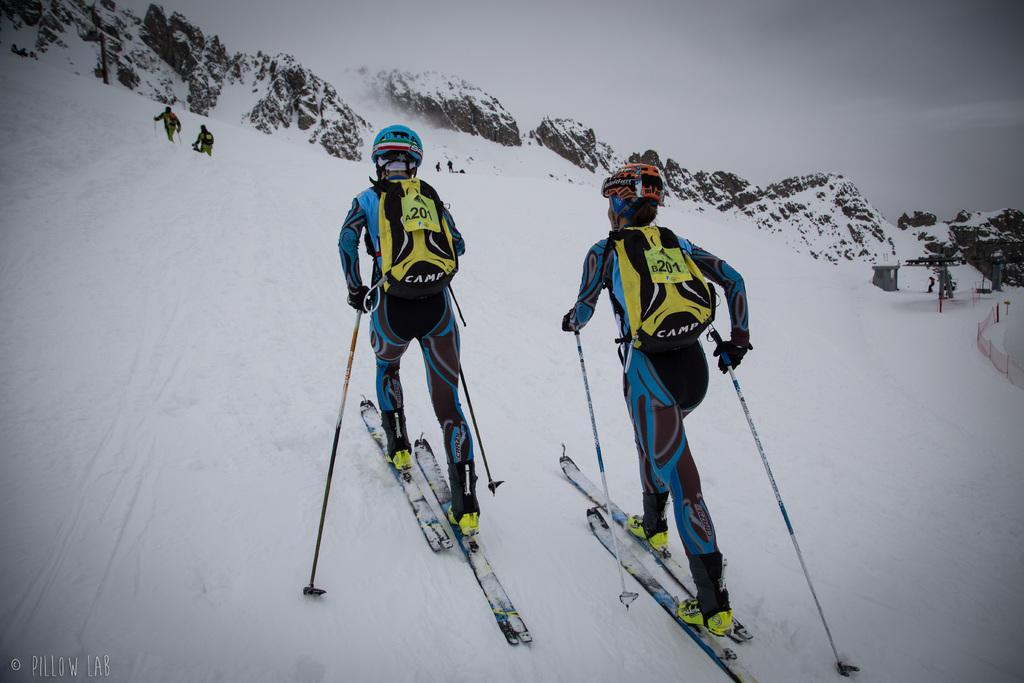What activity are the two people in the image engaged in? The two people in the image are skiing. What are the people wearing while skiing? The people are wearing blue dresses. What are the people carrying while skiing? The people are carrying yellow bags. Can you describe the background of the image? There are mountains in the background of the image. What is present on the right side of the image? There is a red fencing on the right side of the image. How many screws can be seen in the image? There are no screws visible in the image. What color are the toes of the people skiing in the image? The provided facts do not mention the color of the people's toes, and it is not possible to determine this information from the image. 